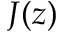<formula> <loc_0><loc_0><loc_500><loc_500>J ( z )</formula> 